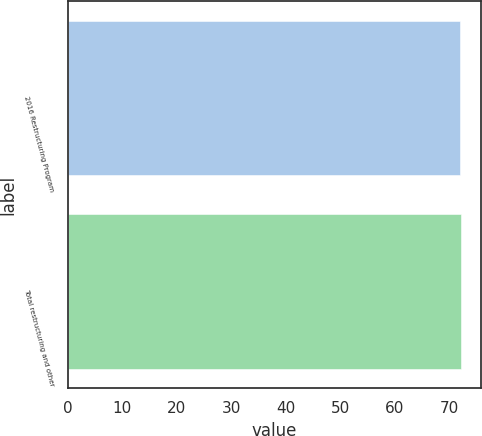Convert chart to OTSL. <chart><loc_0><loc_0><loc_500><loc_500><bar_chart><fcel>2016 Restructuring Program<fcel>Total restructuring and other<nl><fcel>72<fcel>72.1<nl></chart> 